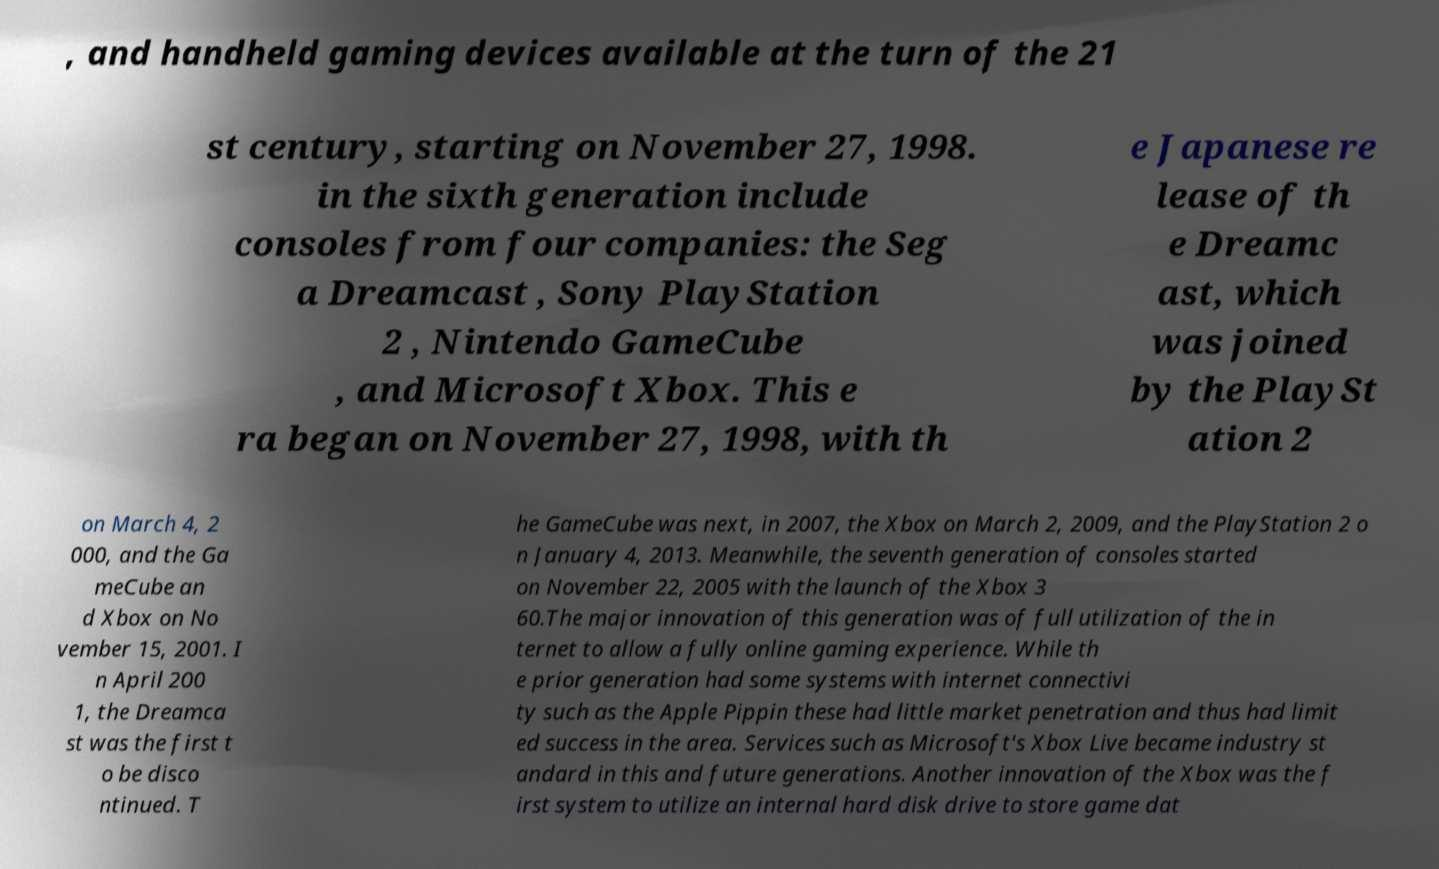For documentation purposes, I need the text within this image transcribed. Could you provide that? , and handheld gaming devices available at the turn of the 21 st century, starting on November 27, 1998. in the sixth generation include consoles from four companies: the Seg a Dreamcast , Sony PlayStation 2 , Nintendo GameCube , and Microsoft Xbox. This e ra began on November 27, 1998, with th e Japanese re lease of th e Dreamc ast, which was joined by the PlaySt ation 2 on March 4, 2 000, and the Ga meCube an d Xbox on No vember 15, 2001. I n April 200 1, the Dreamca st was the first t o be disco ntinued. T he GameCube was next, in 2007, the Xbox on March 2, 2009, and the PlayStation 2 o n January 4, 2013. Meanwhile, the seventh generation of consoles started on November 22, 2005 with the launch of the Xbox 3 60.The major innovation of this generation was of full utilization of the in ternet to allow a fully online gaming experience. While th e prior generation had some systems with internet connectivi ty such as the Apple Pippin these had little market penetration and thus had limit ed success in the area. Services such as Microsoft's Xbox Live became industry st andard in this and future generations. Another innovation of the Xbox was the f irst system to utilize an internal hard disk drive to store game dat 